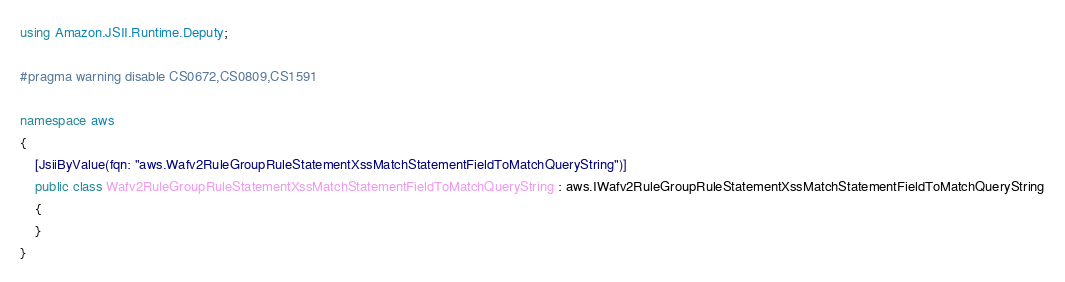Convert code to text. <code><loc_0><loc_0><loc_500><loc_500><_C#_>using Amazon.JSII.Runtime.Deputy;

#pragma warning disable CS0672,CS0809,CS1591

namespace aws
{
    [JsiiByValue(fqn: "aws.Wafv2RuleGroupRuleStatementXssMatchStatementFieldToMatchQueryString")]
    public class Wafv2RuleGroupRuleStatementXssMatchStatementFieldToMatchQueryString : aws.IWafv2RuleGroupRuleStatementXssMatchStatementFieldToMatchQueryString
    {
    }
}
</code> 